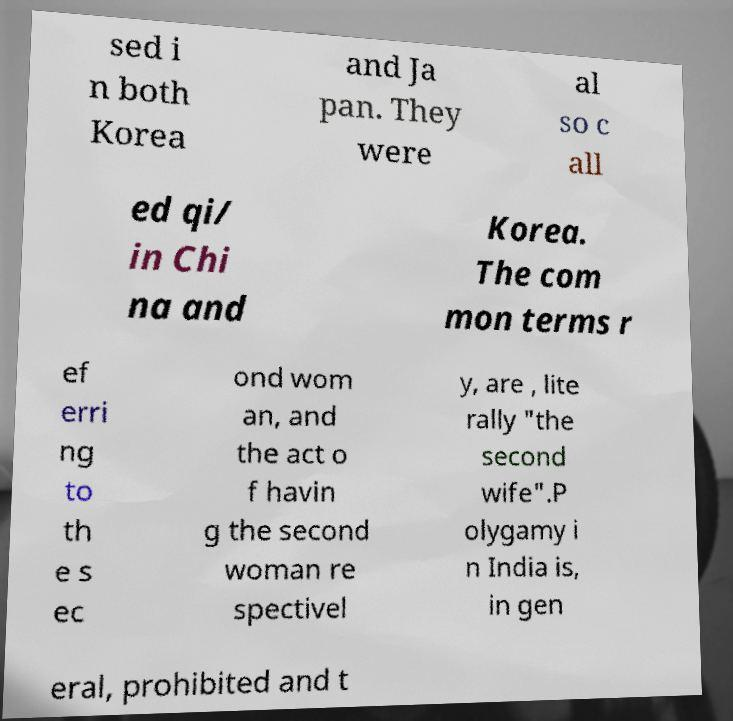I need the written content from this picture converted into text. Can you do that? sed i n both Korea and Ja pan. They were al so c all ed qi/ in Chi na and Korea. The com mon terms r ef erri ng to th e s ec ond wom an, and the act o f havin g the second woman re spectivel y, are , lite rally "the second wife".P olygamy i n India is, in gen eral, prohibited and t 